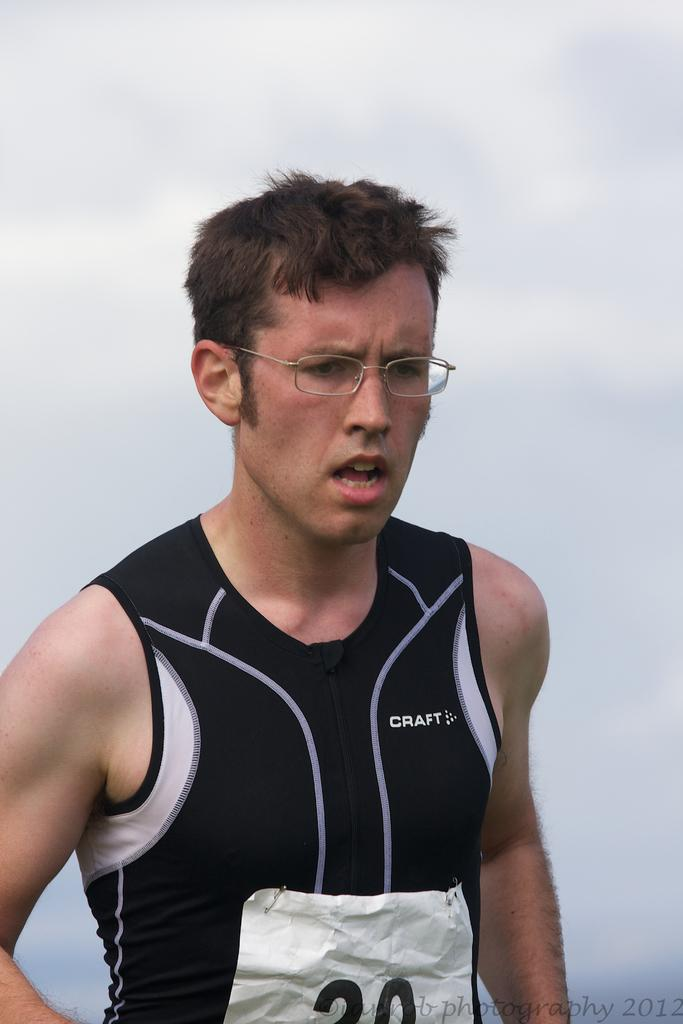<image>
Summarize the visual content of the image. A runner with the word craft on the chest. 